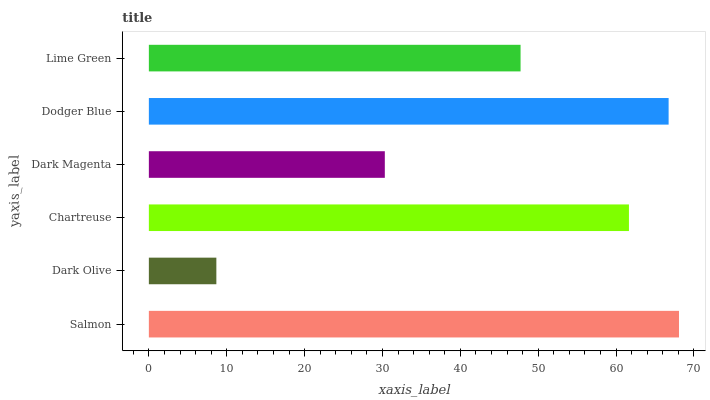Is Dark Olive the minimum?
Answer yes or no. Yes. Is Salmon the maximum?
Answer yes or no. Yes. Is Chartreuse the minimum?
Answer yes or no. No. Is Chartreuse the maximum?
Answer yes or no. No. Is Chartreuse greater than Dark Olive?
Answer yes or no. Yes. Is Dark Olive less than Chartreuse?
Answer yes or no. Yes. Is Dark Olive greater than Chartreuse?
Answer yes or no. No. Is Chartreuse less than Dark Olive?
Answer yes or no. No. Is Chartreuse the high median?
Answer yes or no. Yes. Is Lime Green the low median?
Answer yes or no. Yes. Is Dodger Blue the high median?
Answer yes or no. No. Is Chartreuse the low median?
Answer yes or no. No. 